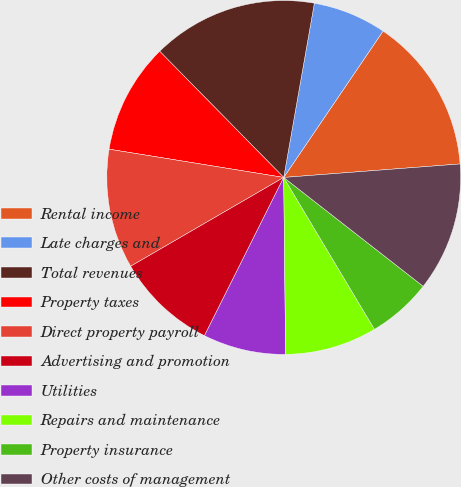<chart> <loc_0><loc_0><loc_500><loc_500><pie_chart><fcel>Rental income<fcel>Late charges and<fcel>Total revenues<fcel>Property taxes<fcel>Direct property payroll<fcel>Advertising and promotion<fcel>Utilities<fcel>Repairs and maintenance<fcel>Property insurance<fcel>Other costs of management<nl><fcel>14.29%<fcel>6.72%<fcel>15.13%<fcel>10.08%<fcel>10.92%<fcel>9.24%<fcel>7.56%<fcel>8.4%<fcel>5.88%<fcel>11.76%<nl></chart> 